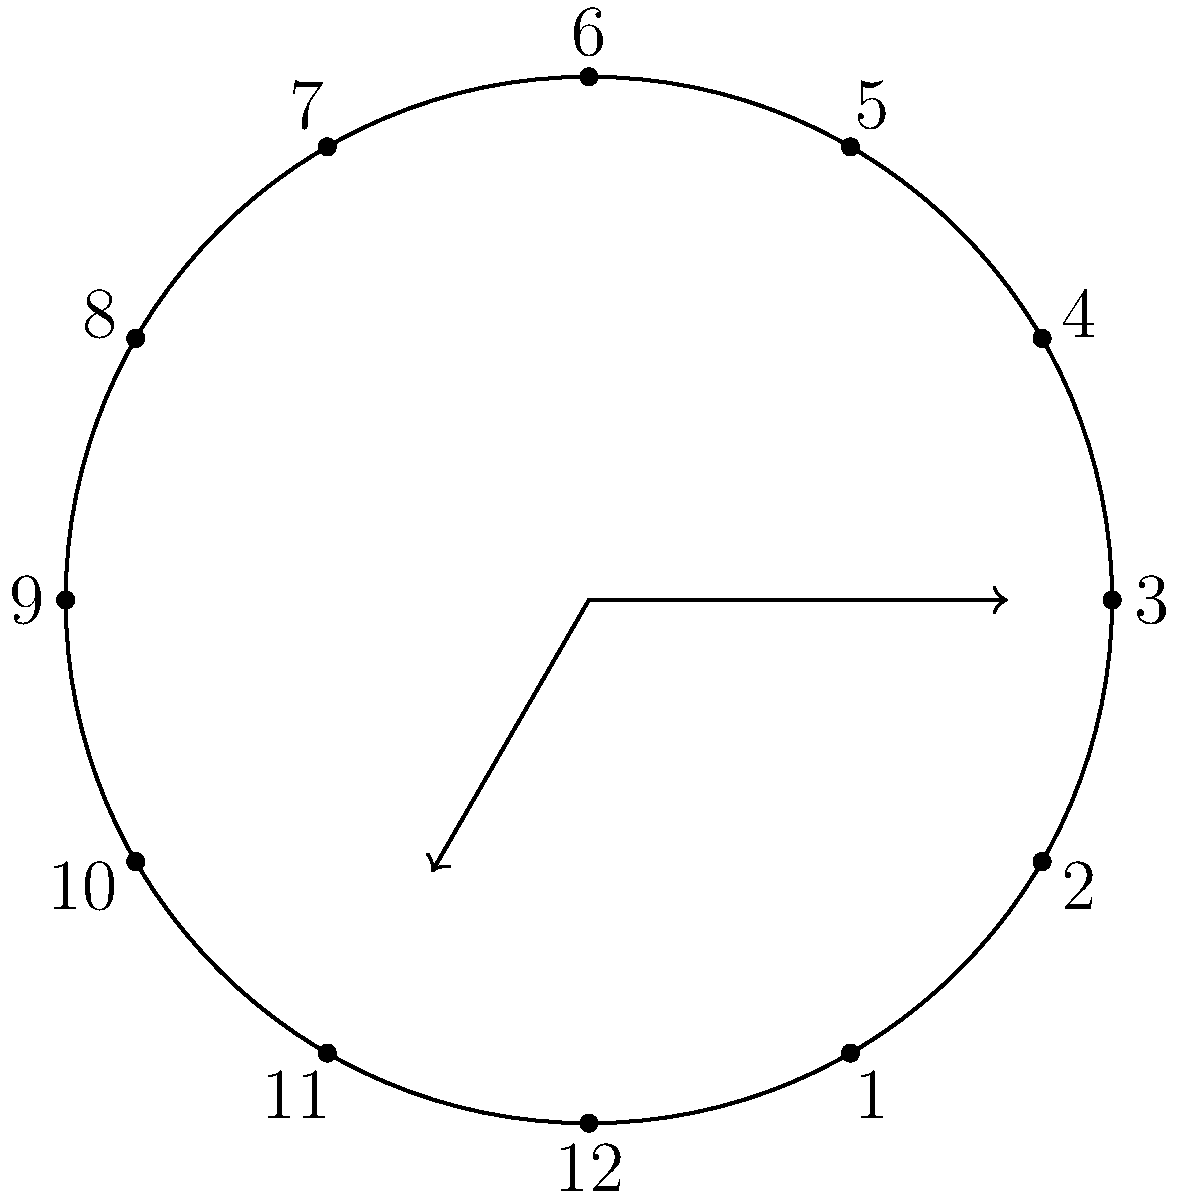In the cyclic group represented by the hands of an analog clock, what is the order of the subgroup generated by the element corresponding to a 5-hour rotation? How might this relate to creating a series of time-lapse artworks for your Instagram followers? To solve this problem, let's follow these steps:

1) In the cyclic group of clock rotations, a complete revolution (12 hours) represents the identity element.

2) A 5-hour rotation is our generator element. Let's call it $a$.

3) To find the order of the subgroup, we need to determine the smallest positive integer $n$ such that $a^n = e$ (the identity element).

4) Let's apply the 5-hour rotation repeatedly:
   $a^1 = 5$ hours
   $a^2 = 10$ hours
   $a^3 = 15$ hours $\equiv 3$ hours (mod 12)
   $a^4 = 20$ hours $\equiv 8$ hours (mod 12)
   $a^5 = 25$ hours $\equiv 1$ hour (mod 12)
   $a^6 = 30$ hours $\equiv 6$ hours (mod 12)
   $a^7 = 35$ hours $\equiv 11$ hours (mod 12)
   $a^8 = 40$ hours $\equiv 4$ hours (mod 12)
   $a^9 = 45$ hours $\equiv 9$ hours (mod 12)
   $a^{10} = 50$ hours $\equiv 2$ hours (mod 12)
   $a^{11} = 55$ hours $\equiv 7$ hours (mod 12)
   $a^{12} = 60$ hours $\equiv 0$ hours (mod 12)

5) We see that $a^{12} = e$, and this is the smallest positive integer where this occurs.

6) Therefore, the order of the subgroup is 12.

Relating to the artist persona: This concept could inspire a series of 12 time-lapse artworks, each representing a 5-hour progression. The series would come full circle after 12 pieces, mirroring the cyclic nature of the clock group. This could be an engaging way to showcase your artistic process and create a cohesive series for your Instagram followers.
Answer: 12 